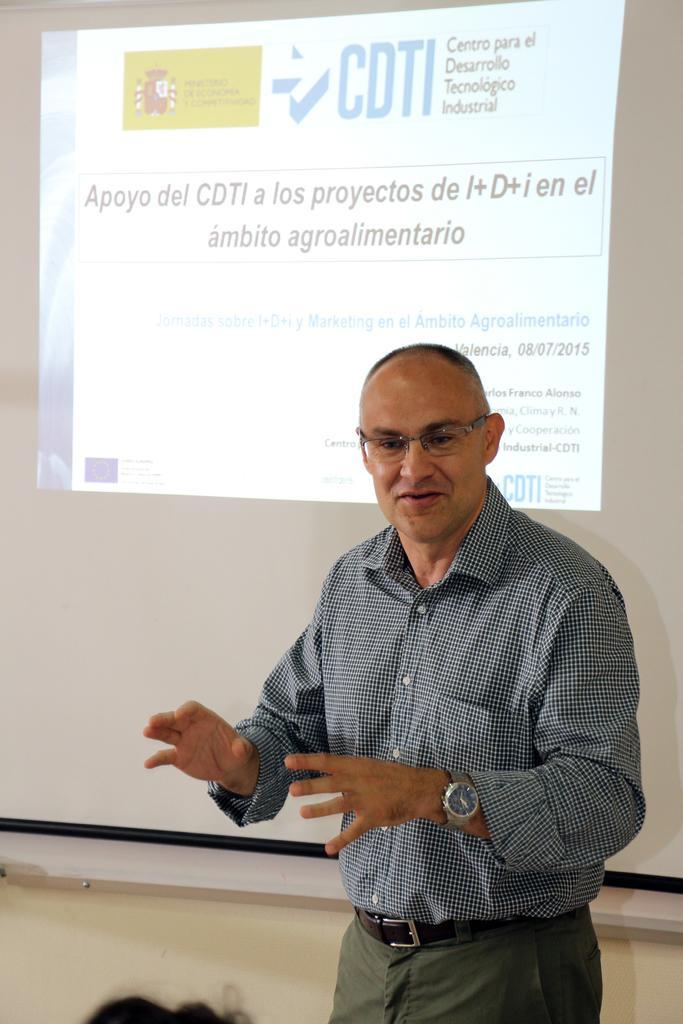In one or two sentences, can you explain what this image depicts? In this image, in the middle, we can see a man. On the left side, we can see hair of a person. In the background, we can see a screen with some pictures and text on it. 